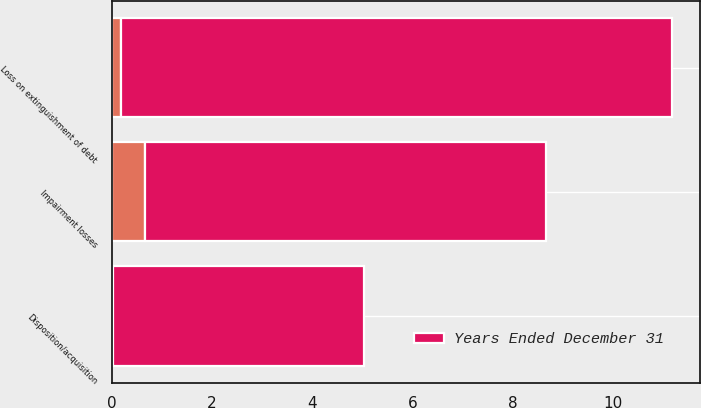Convert chart to OTSL. <chart><loc_0><loc_0><loc_500><loc_500><stacked_bar_chart><ecel><fcel>Disposition/acquisition<fcel>Impairment losses<fcel>Loss on extinguishment of debt<nl><fcel>nan<fcel>0.03<fcel>0.67<fcel>0.18<nl><fcel>Years Ended December 31<fcel>5<fcel>8<fcel>11<nl></chart> 